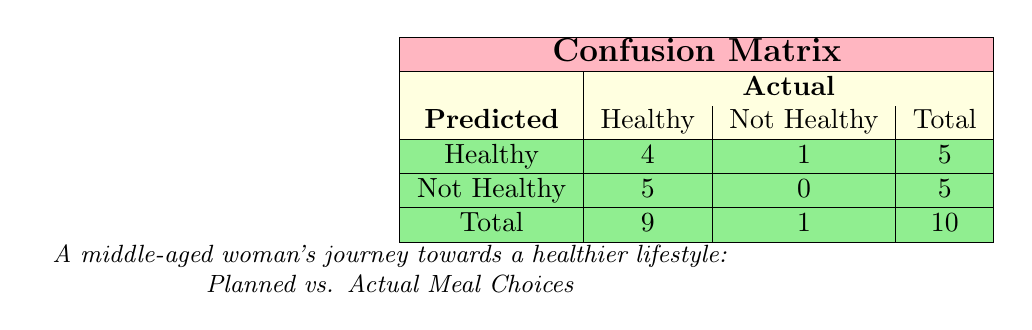What is the total number of planned healthy meals that were actually prepared? From the table, we see that there are 4 true positives (healthy meals that were correctly prepared), which contributes to the total prepared healthy meals. The total number of healthy meals planned is 5 (as seen in the 'Healthy' row). So, 4 are planned and confirmed as prepared.
Answer: 4 How many meals were incorrectly labeled as not healthy? From the 'Not Healthy' row, we can see that there are 5 meals, and since the total from the 'Actual' column is 5, it means these meals were not prepared as planned. Thus, 5 meals were incorrectly labeled as not healthy.
Answer: 5 What is the percentage of meals that were planned and prepared correctly? To find the percentage, divide the number of true positives (4) by the total planned healthy meals (5), and then multiply by 100. This gives (4/5) * 100 = 80%.
Answer: 80% Did any meals that were not healthy get prepared? According to the 'Not Healthy' column under the 'Actual' count, there are 0 meals that are labeled 'Not Healthy' and were actually prepared. This confirms the fact clearly.
Answer: No What is the difference between the number of healthy meals planned and healthy meals that were actually prepared? The number of planned healthy meals is 5 and the number of actual healthy meals prepared is 4. Thus, the difference is 5 - 4 = 1 meal.
Answer: 1 What is the ratio of meals correctly prepared to those that were not? Looking at the table, 4 meals were correctly prepared (True Positives) and 5 were not (sum of False Negatives and False Positives). The ratio is therefore 4:5.
Answer: 4:5 How many meals were planned but not prepared? To find this, we look at the sum of False Negatives and False Positives. The false negatives total 5 and there is 1 False Positive, so in total, there are 5 + 1 = 6 meals that were planned but not prepared.
Answer: 6 Was the planned "Greek Yogurt with Honey and Nuts" meal prepared correctly? Referring to the table, we notice that this meal is listed as a False Positive, indicating that it was planned but a different version (with berries) was actually prepared. Therefore, it was not prepared correctly.
Answer: No What is the total number of meals planned? Adding the total healthy meals (5) and the total not healthy meals (0), we find that there are 5 meals planned in total.
Answer: 10 